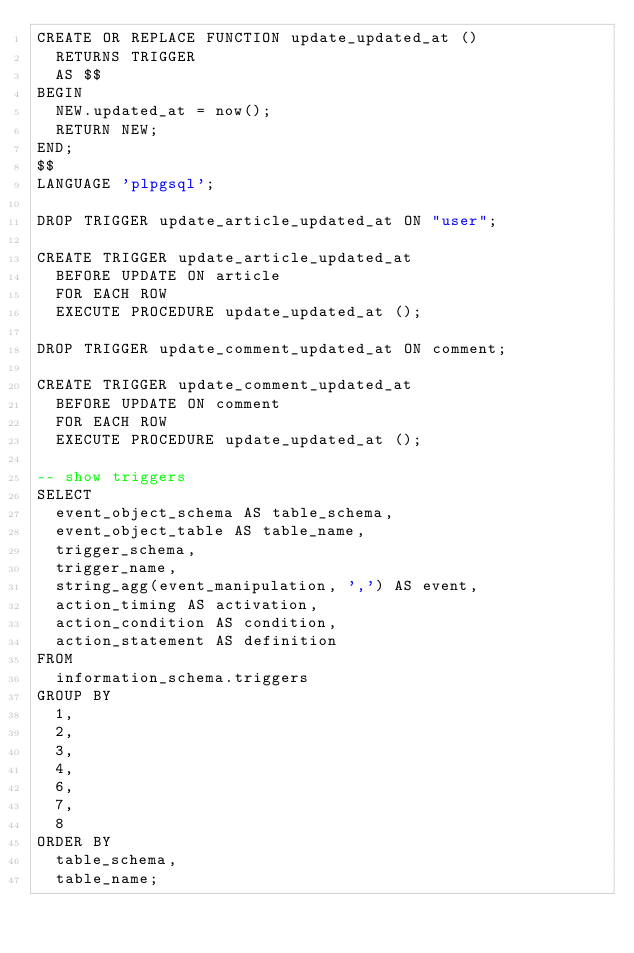<code> <loc_0><loc_0><loc_500><loc_500><_SQL_>CREATE OR REPLACE FUNCTION update_updated_at ()
  RETURNS TRIGGER
  AS $$
BEGIN
  NEW.updated_at = now();
  RETURN NEW;
END;
$$
LANGUAGE 'plpgsql';

DROP TRIGGER update_article_updated_at ON "user";

CREATE TRIGGER update_article_updated_at
  BEFORE UPDATE ON article
  FOR EACH ROW
  EXECUTE PROCEDURE update_updated_at ();

DROP TRIGGER update_comment_updated_at ON comment;

CREATE TRIGGER update_comment_updated_at
  BEFORE UPDATE ON comment
  FOR EACH ROW
  EXECUTE PROCEDURE update_updated_at ();

-- show triggers
SELECT
  event_object_schema AS table_schema,
  event_object_table AS table_name,
  trigger_schema,
  trigger_name,
  string_agg(event_manipulation, ',') AS event,
  action_timing AS activation,
  action_condition AS condition,
  action_statement AS definition
FROM
  information_schema.triggers
GROUP BY
  1,
  2,
  3,
  4,
  6,
  7,
  8
ORDER BY
  table_schema,
  table_name;

</code> 